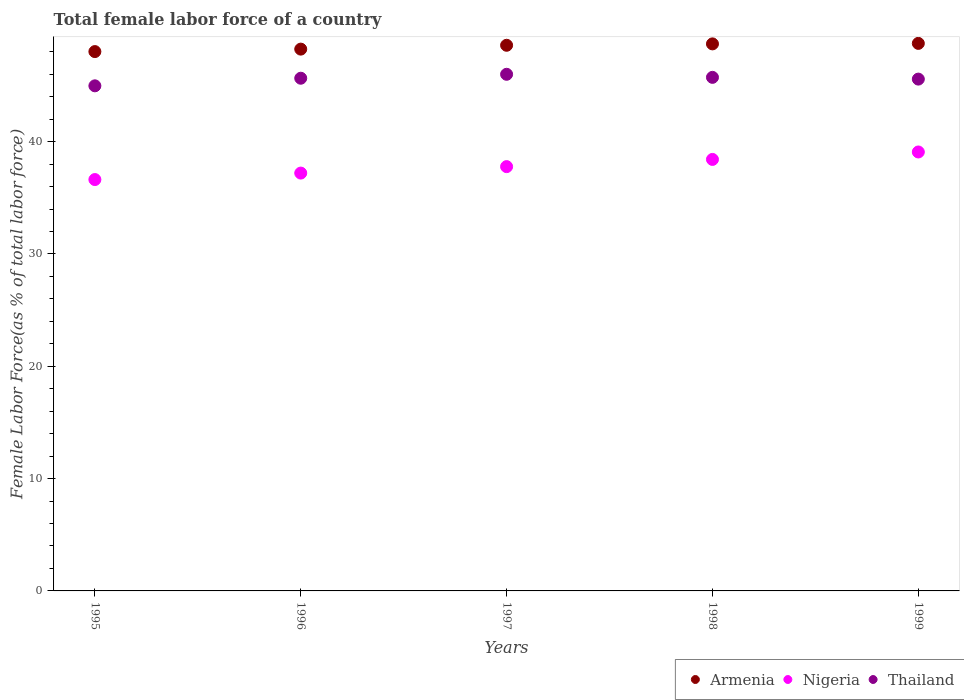What is the percentage of female labor force in Nigeria in 1997?
Keep it short and to the point. 37.78. Across all years, what is the maximum percentage of female labor force in Thailand?
Your answer should be compact. 46. Across all years, what is the minimum percentage of female labor force in Nigeria?
Give a very brief answer. 36.62. What is the total percentage of female labor force in Armenia in the graph?
Keep it short and to the point. 242.29. What is the difference between the percentage of female labor force in Thailand in 1995 and that in 1997?
Offer a terse response. -1.03. What is the difference between the percentage of female labor force in Nigeria in 1997 and the percentage of female labor force in Thailand in 1999?
Offer a terse response. -7.79. What is the average percentage of female labor force in Thailand per year?
Your answer should be compact. 45.58. In the year 1997, what is the difference between the percentage of female labor force in Nigeria and percentage of female labor force in Armenia?
Ensure brevity in your answer.  -10.8. In how many years, is the percentage of female labor force in Armenia greater than 22 %?
Offer a very short reply. 5. What is the ratio of the percentage of female labor force in Nigeria in 1995 to that in 1998?
Ensure brevity in your answer.  0.95. What is the difference between the highest and the second highest percentage of female labor force in Thailand?
Keep it short and to the point. 0.27. What is the difference between the highest and the lowest percentage of female labor force in Nigeria?
Make the answer very short. 2.46. Is the sum of the percentage of female labor force in Armenia in 1997 and 1998 greater than the maximum percentage of female labor force in Nigeria across all years?
Make the answer very short. Yes. Is it the case that in every year, the sum of the percentage of female labor force in Armenia and percentage of female labor force in Thailand  is greater than the percentage of female labor force in Nigeria?
Your response must be concise. Yes. How many years are there in the graph?
Your response must be concise. 5. What is the difference between two consecutive major ticks on the Y-axis?
Ensure brevity in your answer.  10. Are the values on the major ticks of Y-axis written in scientific E-notation?
Your answer should be compact. No. How many legend labels are there?
Give a very brief answer. 3. How are the legend labels stacked?
Keep it short and to the point. Horizontal. What is the title of the graph?
Your answer should be very brief. Total female labor force of a country. Does "Azerbaijan" appear as one of the legend labels in the graph?
Keep it short and to the point. No. What is the label or title of the Y-axis?
Your answer should be very brief. Female Labor Force(as % of total labor force). What is the Female Labor Force(as % of total labor force) in Armenia in 1995?
Your answer should be very brief. 48.02. What is the Female Labor Force(as % of total labor force) of Nigeria in 1995?
Offer a terse response. 36.62. What is the Female Labor Force(as % of total labor force) in Thailand in 1995?
Offer a terse response. 44.97. What is the Female Labor Force(as % of total labor force) in Armenia in 1996?
Provide a succinct answer. 48.24. What is the Female Labor Force(as % of total labor force) in Nigeria in 1996?
Your answer should be compact. 37.2. What is the Female Labor Force(as % of total labor force) in Thailand in 1996?
Make the answer very short. 45.65. What is the Female Labor Force(as % of total labor force) of Armenia in 1997?
Your response must be concise. 48.58. What is the Female Labor Force(as % of total labor force) in Nigeria in 1997?
Provide a short and direct response. 37.78. What is the Female Labor Force(as % of total labor force) in Thailand in 1997?
Offer a terse response. 46. What is the Female Labor Force(as % of total labor force) of Armenia in 1998?
Offer a very short reply. 48.7. What is the Female Labor Force(as % of total labor force) in Nigeria in 1998?
Ensure brevity in your answer.  38.42. What is the Female Labor Force(as % of total labor force) of Thailand in 1998?
Give a very brief answer. 45.72. What is the Female Labor Force(as % of total labor force) of Armenia in 1999?
Offer a very short reply. 48.75. What is the Female Labor Force(as % of total labor force) of Nigeria in 1999?
Give a very brief answer. 39.08. What is the Female Labor Force(as % of total labor force) of Thailand in 1999?
Offer a terse response. 45.57. Across all years, what is the maximum Female Labor Force(as % of total labor force) in Armenia?
Your answer should be compact. 48.75. Across all years, what is the maximum Female Labor Force(as % of total labor force) of Nigeria?
Offer a terse response. 39.08. Across all years, what is the maximum Female Labor Force(as % of total labor force) in Thailand?
Give a very brief answer. 46. Across all years, what is the minimum Female Labor Force(as % of total labor force) in Armenia?
Keep it short and to the point. 48.02. Across all years, what is the minimum Female Labor Force(as % of total labor force) of Nigeria?
Provide a succinct answer. 36.62. Across all years, what is the minimum Female Labor Force(as % of total labor force) of Thailand?
Your answer should be compact. 44.97. What is the total Female Labor Force(as % of total labor force) of Armenia in the graph?
Provide a succinct answer. 242.29. What is the total Female Labor Force(as % of total labor force) in Nigeria in the graph?
Offer a terse response. 189.1. What is the total Female Labor Force(as % of total labor force) in Thailand in the graph?
Offer a very short reply. 227.91. What is the difference between the Female Labor Force(as % of total labor force) in Armenia in 1995 and that in 1996?
Offer a terse response. -0.22. What is the difference between the Female Labor Force(as % of total labor force) of Nigeria in 1995 and that in 1996?
Your response must be concise. -0.58. What is the difference between the Female Labor Force(as % of total labor force) of Thailand in 1995 and that in 1996?
Your response must be concise. -0.68. What is the difference between the Female Labor Force(as % of total labor force) in Armenia in 1995 and that in 1997?
Offer a very short reply. -0.56. What is the difference between the Female Labor Force(as % of total labor force) in Nigeria in 1995 and that in 1997?
Your answer should be very brief. -1.15. What is the difference between the Female Labor Force(as % of total labor force) of Thailand in 1995 and that in 1997?
Give a very brief answer. -1.03. What is the difference between the Female Labor Force(as % of total labor force) in Armenia in 1995 and that in 1998?
Make the answer very short. -0.69. What is the difference between the Female Labor Force(as % of total labor force) of Nigeria in 1995 and that in 1998?
Your answer should be compact. -1.79. What is the difference between the Female Labor Force(as % of total labor force) in Thailand in 1995 and that in 1998?
Provide a succinct answer. -0.75. What is the difference between the Female Labor Force(as % of total labor force) of Armenia in 1995 and that in 1999?
Provide a succinct answer. -0.73. What is the difference between the Female Labor Force(as % of total labor force) in Nigeria in 1995 and that in 1999?
Make the answer very short. -2.46. What is the difference between the Female Labor Force(as % of total labor force) in Thailand in 1995 and that in 1999?
Keep it short and to the point. -0.6. What is the difference between the Female Labor Force(as % of total labor force) in Armenia in 1996 and that in 1997?
Provide a succinct answer. -0.34. What is the difference between the Female Labor Force(as % of total labor force) in Nigeria in 1996 and that in 1997?
Your response must be concise. -0.57. What is the difference between the Female Labor Force(as % of total labor force) of Thailand in 1996 and that in 1997?
Offer a terse response. -0.35. What is the difference between the Female Labor Force(as % of total labor force) of Armenia in 1996 and that in 1998?
Give a very brief answer. -0.47. What is the difference between the Female Labor Force(as % of total labor force) of Nigeria in 1996 and that in 1998?
Your response must be concise. -1.22. What is the difference between the Female Labor Force(as % of total labor force) in Thailand in 1996 and that in 1998?
Offer a terse response. -0.08. What is the difference between the Female Labor Force(as % of total labor force) of Armenia in 1996 and that in 1999?
Provide a short and direct response. -0.51. What is the difference between the Female Labor Force(as % of total labor force) in Nigeria in 1996 and that in 1999?
Offer a terse response. -1.88. What is the difference between the Female Labor Force(as % of total labor force) in Thailand in 1996 and that in 1999?
Your response must be concise. 0.08. What is the difference between the Female Labor Force(as % of total labor force) of Armenia in 1997 and that in 1998?
Your answer should be compact. -0.12. What is the difference between the Female Labor Force(as % of total labor force) in Nigeria in 1997 and that in 1998?
Provide a short and direct response. -0.64. What is the difference between the Female Labor Force(as % of total labor force) of Thailand in 1997 and that in 1998?
Your answer should be compact. 0.27. What is the difference between the Female Labor Force(as % of total labor force) in Armenia in 1997 and that in 1999?
Keep it short and to the point. -0.17. What is the difference between the Female Labor Force(as % of total labor force) in Nigeria in 1997 and that in 1999?
Keep it short and to the point. -1.3. What is the difference between the Female Labor Force(as % of total labor force) of Thailand in 1997 and that in 1999?
Keep it short and to the point. 0.43. What is the difference between the Female Labor Force(as % of total labor force) in Armenia in 1998 and that in 1999?
Provide a succinct answer. -0.04. What is the difference between the Female Labor Force(as % of total labor force) in Nigeria in 1998 and that in 1999?
Ensure brevity in your answer.  -0.66. What is the difference between the Female Labor Force(as % of total labor force) of Thailand in 1998 and that in 1999?
Ensure brevity in your answer.  0.16. What is the difference between the Female Labor Force(as % of total labor force) in Armenia in 1995 and the Female Labor Force(as % of total labor force) in Nigeria in 1996?
Your answer should be very brief. 10.82. What is the difference between the Female Labor Force(as % of total labor force) in Armenia in 1995 and the Female Labor Force(as % of total labor force) in Thailand in 1996?
Your answer should be very brief. 2.37. What is the difference between the Female Labor Force(as % of total labor force) of Nigeria in 1995 and the Female Labor Force(as % of total labor force) of Thailand in 1996?
Provide a short and direct response. -9.02. What is the difference between the Female Labor Force(as % of total labor force) in Armenia in 1995 and the Female Labor Force(as % of total labor force) in Nigeria in 1997?
Offer a terse response. 10.24. What is the difference between the Female Labor Force(as % of total labor force) in Armenia in 1995 and the Female Labor Force(as % of total labor force) in Thailand in 1997?
Keep it short and to the point. 2.02. What is the difference between the Female Labor Force(as % of total labor force) of Nigeria in 1995 and the Female Labor Force(as % of total labor force) of Thailand in 1997?
Offer a terse response. -9.37. What is the difference between the Female Labor Force(as % of total labor force) of Armenia in 1995 and the Female Labor Force(as % of total labor force) of Nigeria in 1998?
Provide a short and direct response. 9.6. What is the difference between the Female Labor Force(as % of total labor force) of Armenia in 1995 and the Female Labor Force(as % of total labor force) of Thailand in 1998?
Keep it short and to the point. 2.29. What is the difference between the Female Labor Force(as % of total labor force) in Nigeria in 1995 and the Female Labor Force(as % of total labor force) in Thailand in 1998?
Offer a terse response. -9.1. What is the difference between the Female Labor Force(as % of total labor force) of Armenia in 1995 and the Female Labor Force(as % of total labor force) of Nigeria in 1999?
Give a very brief answer. 8.94. What is the difference between the Female Labor Force(as % of total labor force) of Armenia in 1995 and the Female Labor Force(as % of total labor force) of Thailand in 1999?
Provide a succinct answer. 2.45. What is the difference between the Female Labor Force(as % of total labor force) in Nigeria in 1995 and the Female Labor Force(as % of total labor force) in Thailand in 1999?
Your answer should be compact. -8.94. What is the difference between the Female Labor Force(as % of total labor force) in Armenia in 1996 and the Female Labor Force(as % of total labor force) in Nigeria in 1997?
Your response must be concise. 10.46. What is the difference between the Female Labor Force(as % of total labor force) of Armenia in 1996 and the Female Labor Force(as % of total labor force) of Thailand in 1997?
Your response must be concise. 2.24. What is the difference between the Female Labor Force(as % of total labor force) in Nigeria in 1996 and the Female Labor Force(as % of total labor force) in Thailand in 1997?
Offer a terse response. -8.8. What is the difference between the Female Labor Force(as % of total labor force) of Armenia in 1996 and the Female Labor Force(as % of total labor force) of Nigeria in 1998?
Your answer should be very brief. 9.82. What is the difference between the Female Labor Force(as % of total labor force) in Armenia in 1996 and the Female Labor Force(as % of total labor force) in Thailand in 1998?
Your answer should be compact. 2.51. What is the difference between the Female Labor Force(as % of total labor force) in Nigeria in 1996 and the Female Labor Force(as % of total labor force) in Thailand in 1998?
Offer a terse response. -8.52. What is the difference between the Female Labor Force(as % of total labor force) of Armenia in 1996 and the Female Labor Force(as % of total labor force) of Nigeria in 1999?
Your answer should be very brief. 9.16. What is the difference between the Female Labor Force(as % of total labor force) of Armenia in 1996 and the Female Labor Force(as % of total labor force) of Thailand in 1999?
Keep it short and to the point. 2.67. What is the difference between the Female Labor Force(as % of total labor force) of Nigeria in 1996 and the Female Labor Force(as % of total labor force) of Thailand in 1999?
Your response must be concise. -8.37. What is the difference between the Female Labor Force(as % of total labor force) in Armenia in 1997 and the Female Labor Force(as % of total labor force) in Nigeria in 1998?
Ensure brevity in your answer.  10.16. What is the difference between the Female Labor Force(as % of total labor force) of Armenia in 1997 and the Female Labor Force(as % of total labor force) of Thailand in 1998?
Ensure brevity in your answer.  2.86. What is the difference between the Female Labor Force(as % of total labor force) of Nigeria in 1997 and the Female Labor Force(as % of total labor force) of Thailand in 1998?
Your response must be concise. -7.95. What is the difference between the Female Labor Force(as % of total labor force) in Armenia in 1997 and the Female Labor Force(as % of total labor force) in Nigeria in 1999?
Offer a very short reply. 9.5. What is the difference between the Female Labor Force(as % of total labor force) in Armenia in 1997 and the Female Labor Force(as % of total labor force) in Thailand in 1999?
Your response must be concise. 3.01. What is the difference between the Female Labor Force(as % of total labor force) of Nigeria in 1997 and the Female Labor Force(as % of total labor force) of Thailand in 1999?
Your answer should be compact. -7.79. What is the difference between the Female Labor Force(as % of total labor force) in Armenia in 1998 and the Female Labor Force(as % of total labor force) in Nigeria in 1999?
Your answer should be compact. 9.62. What is the difference between the Female Labor Force(as % of total labor force) in Armenia in 1998 and the Female Labor Force(as % of total labor force) in Thailand in 1999?
Offer a very short reply. 3.14. What is the difference between the Female Labor Force(as % of total labor force) of Nigeria in 1998 and the Female Labor Force(as % of total labor force) of Thailand in 1999?
Your answer should be very brief. -7.15. What is the average Female Labor Force(as % of total labor force) in Armenia per year?
Your answer should be very brief. 48.46. What is the average Female Labor Force(as % of total labor force) in Nigeria per year?
Your answer should be compact. 37.82. What is the average Female Labor Force(as % of total labor force) in Thailand per year?
Your response must be concise. 45.58. In the year 1995, what is the difference between the Female Labor Force(as % of total labor force) in Armenia and Female Labor Force(as % of total labor force) in Nigeria?
Give a very brief answer. 11.39. In the year 1995, what is the difference between the Female Labor Force(as % of total labor force) of Armenia and Female Labor Force(as % of total labor force) of Thailand?
Your answer should be compact. 3.05. In the year 1995, what is the difference between the Female Labor Force(as % of total labor force) of Nigeria and Female Labor Force(as % of total labor force) of Thailand?
Keep it short and to the point. -8.35. In the year 1996, what is the difference between the Female Labor Force(as % of total labor force) of Armenia and Female Labor Force(as % of total labor force) of Nigeria?
Offer a terse response. 11.04. In the year 1996, what is the difference between the Female Labor Force(as % of total labor force) in Armenia and Female Labor Force(as % of total labor force) in Thailand?
Provide a succinct answer. 2.59. In the year 1996, what is the difference between the Female Labor Force(as % of total labor force) in Nigeria and Female Labor Force(as % of total labor force) in Thailand?
Provide a succinct answer. -8.45. In the year 1997, what is the difference between the Female Labor Force(as % of total labor force) in Armenia and Female Labor Force(as % of total labor force) in Nigeria?
Provide a succinct answer. 10.8. In the year 1997, what is the difference between the Female Labor Force(as % of total labor force) in Armenia and Female Labor Force(as % of total labor force) in Thailand?
Your answer should be very brief. 2.58. In the year 1997, what is the difference between the Female Labor Force(as % of total labor force) in Nigeria and Female Labor Force(as % of total labor force) in Thailand?
Keep it short and to the point. -8.22. In the year 1998, what is the difference between the Female Labor Force(as % of total labor force) in Armenia and Female Labor Force(as % of total labor force) in Nigeria?
Make the answer very short. 10.29. In the year 1998, what is the difference between the Female Labor Force(as % of total labor force) in Armenia and Female Labor Force(as % of total labor force) in Thailand?
Your answer should be very brief. 2.98. In the year 1998, what is the difference between the Female Labor Force(as % of total labor force) of Nigeria and Female Labor Force(as % of total labor force) of Thailand?
Your response must be concise. -7.31. In the year 1999, what is the difference between the Female Labor Force(as % of total labor force) of Armenia and Female Labor Force(as % of total labor force) of Nigeria?
Offer a terse response. 9.67. In the year 1999, what is the difference between the Female Labor Force(as % of total labor force) in Armenia and Female Labor Force(as % of total labor force) in Thailand?
Your response must be concise. 3.18. In the year 1999, what is the difference between the Female Labor Force(as % of total labor force) of Nigeria and Female Labor Force(as % of total labor force) of Thailand?
Your answer should be compact. -6.49. What is the ratio of the Female Labor Force(as % of total labor force) of Nigeria in 1995 to that in 1996?
Offer a terse response. 0.98. What is the ratio of the Female Labor Force(as % of total labor force) of Thailand in 1995 to that in 1996?
Offer a very short reply. 0.99. What is the ratio of the Female Labor Force(as % of total labor force) in Armenia in 1995 to that in 1997?
Offer a terse response. 0.99. What is the ratio of the Female Labor Force(as % of total labor force) of Nigeria in 1995 to that in 1997?
Give a very brief answer. 0.97. What is the ratio of the Female Labor Force(as % of total labor force) in Thailand in 1995 to that in 1997?
Provide a succinct answer. 0.98. What is the ratio of the Female Labor Force(as % of total labor force) of Armenia in 1995 to that in 1998?
Your answer should be compact. 0.99. What is the ratio of the Female Labor Force(as % of total labor force) in Nigeria in 1995 to that in 1998?
Your answer should be very brief. 0.95. What is the ratio of the Female Labor Force(as % of total labor force) of Thailand in 1995 to that in 1998?
Provide a succinct answer. 0.98. What is the ratio of the Female Labor Force(as % of total labor force) of Nigeria in 1995 to that in 1999?
Offer a very short reply. 0.94. What is the ratio of the Female Labor Force(as % of total labor force) of Thailand in 1995 to that in 1999?
Your answer should be very brief. 0.99. What is the ratio of the Female Labor Force(as % of total labor force) in Nigeria in 1996 to that in 1997?
Provide a succinct answer. 0.98. What is the ratio of the Female Labor Force(as % of total labor force) in Thailand in 1996 to that in 1997?
Your response must be concise. 0.99. What is the ratio of the Female Labor Force(as % of total labor force) in Nigeria in 1996 to that in 1998?
Ensure brevity in your answer.  0.97. What is the ratio of the Female Labor Force(as % of total labor force) of Nigeria in 1996 to that in 1999?
Your response must be concise. 0.95. What is the ratio of the Female Labor Force(as % of total labor force) of Nigeria in 1997 to that in 1998?
Make the answer very short. 0.98. What is the ratio of the Female Labor Force(as % of total labor force) in Armenia in 1997 to that in 1999?
Offer a terse response. 1. What is the ratio of the Female Labor Force(as % of total labor force) in Nigeria in 1997 to that in 1999?
Give a very brief answer. 0.97. What is the ratio of the Female Labor Force(as % of total labor force) of Thailand in 1997 to that in 1999?
Offer a terse response. 1.01. What is the ratio of the Female Labor Force(as % of total labor force) of Armenia in 1998 to that in 1999?
Make the answer very short. 1. What is the difference between the highest and the second highest Female Labor Force(as % of total labor force) in Armenia?
Provide a short and direct response. 0.04. What is the difference between the highest and the second highest Female Labor Force(as % of total labor force) in Nigeria?
Give a very brief answer. 0.66. What is the difference between the highest and the second highest Female Labor Force(as % of total labor force) in Thailand?
Your answer should be very brief. 0.27. What is the difference between the highest and the lowest Female Labor Force(as % of total labor force) of Armenia?
Make the answer very short. 0.73. What is the difference between the highest and the lowest Female Labor Force(as % of total labor force) of Nigeria?
Ensure brevity in your answer.  2.46. What is the difference between the highest and the lowest Female Labor Force(as % of total labor force) of Thailand?
Make the answer very short. 1.03. 